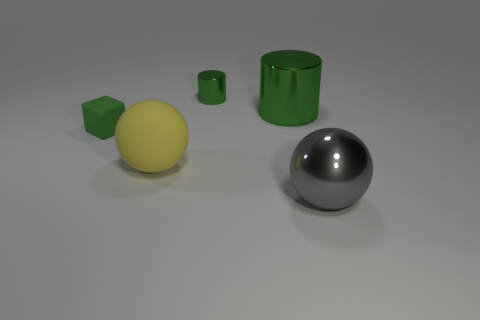Subtract all cylinders. How many objects are left? 3 Add 3 blue rubber cylinders. How many objects exist? 8 Subtract all large yellow balls. Subtract all large gray spheres. How many objects are left? 3 Add 2 small green shiny things. How many small green shiny things are left? 3 Add 5 blue matte cylinders. How many blue matte cylinders exist? 5 Subtract 0 red cylinders. How many objects are left? 5 